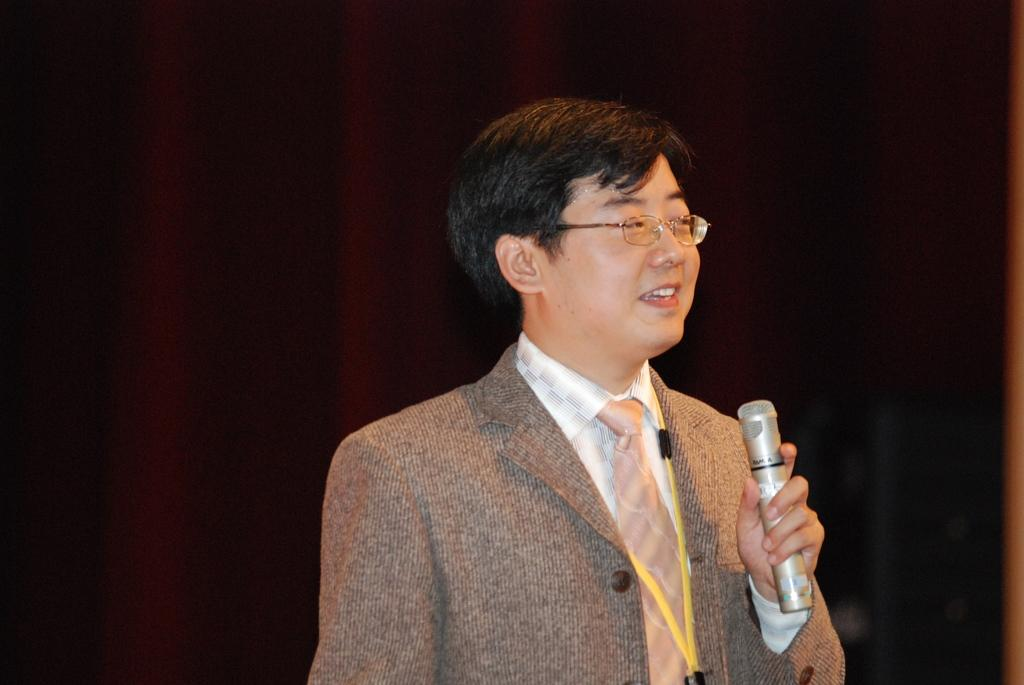Who is present in the image? There is a man in the image. What is the man wearing? The man is wearing a suit. What object is the man holding in the image? The man is holding a microphone. What type of seed is the man planting in the image? There is no seed or planting activity present in the image; the man is holding a microphone. 